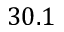Convert formula to latex. <formula><loc_0><loc_0><loc_500><loc_500>3 0 . 1</formula> 